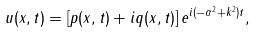<formula> <loc_0><loc_0><loc_500><loc_500>u ( x , t ) = [ p ( x , t ) + i q ( x , t ) ] \, e ^ { i ( - \alpha ^ { 2 } + k ^ { 2 } ) t } ,</formula> 